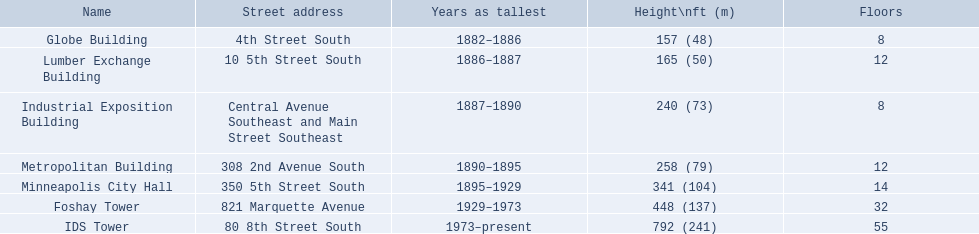What are the vertical measurements of the buildings? 157 (48), 165 (50), 240 (73), 258 (79), 341 (104), 448 (137), 792 (241). Which construction is 240 ft tall? Industrial Exposition Building. 